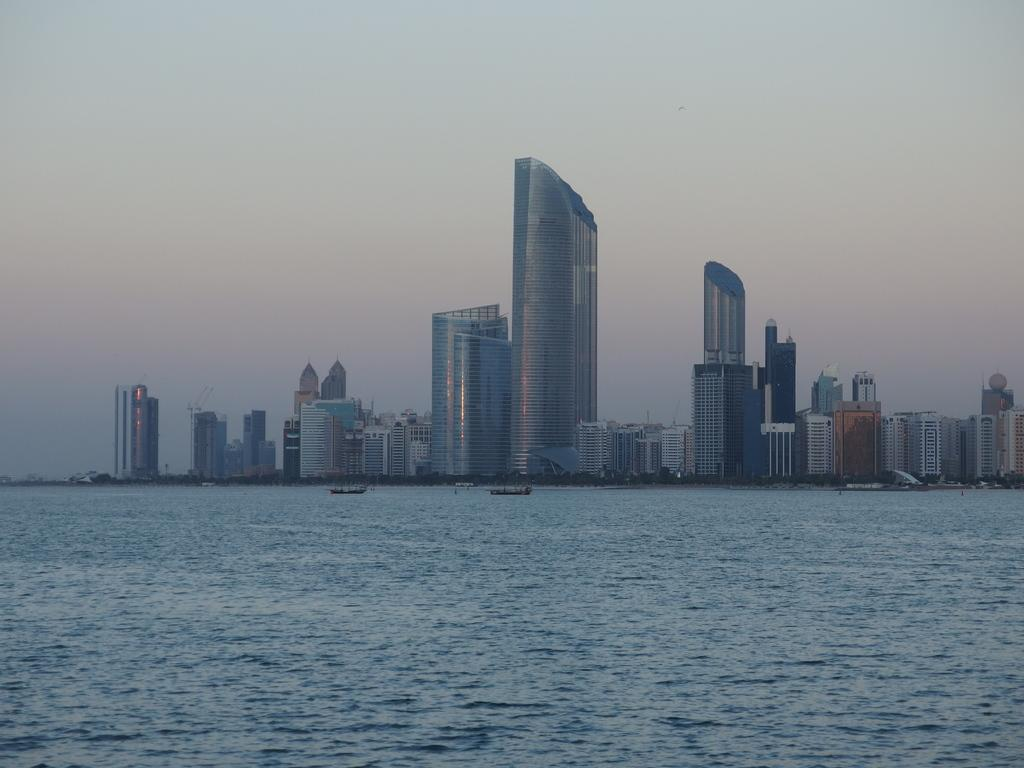What is the primary element in the image? There is water in the image. What is on the water? There are boats on the water. What can be seen in the background of the image? There are buildings in the background of the image. What is visible above the water and buildings? The sky is visible in the image. Who is the owner of the thing that is not present in the image? There is no specific "thing" mentioned in the image, and therefore, it is impossible to determine the owner of something that is not present. 